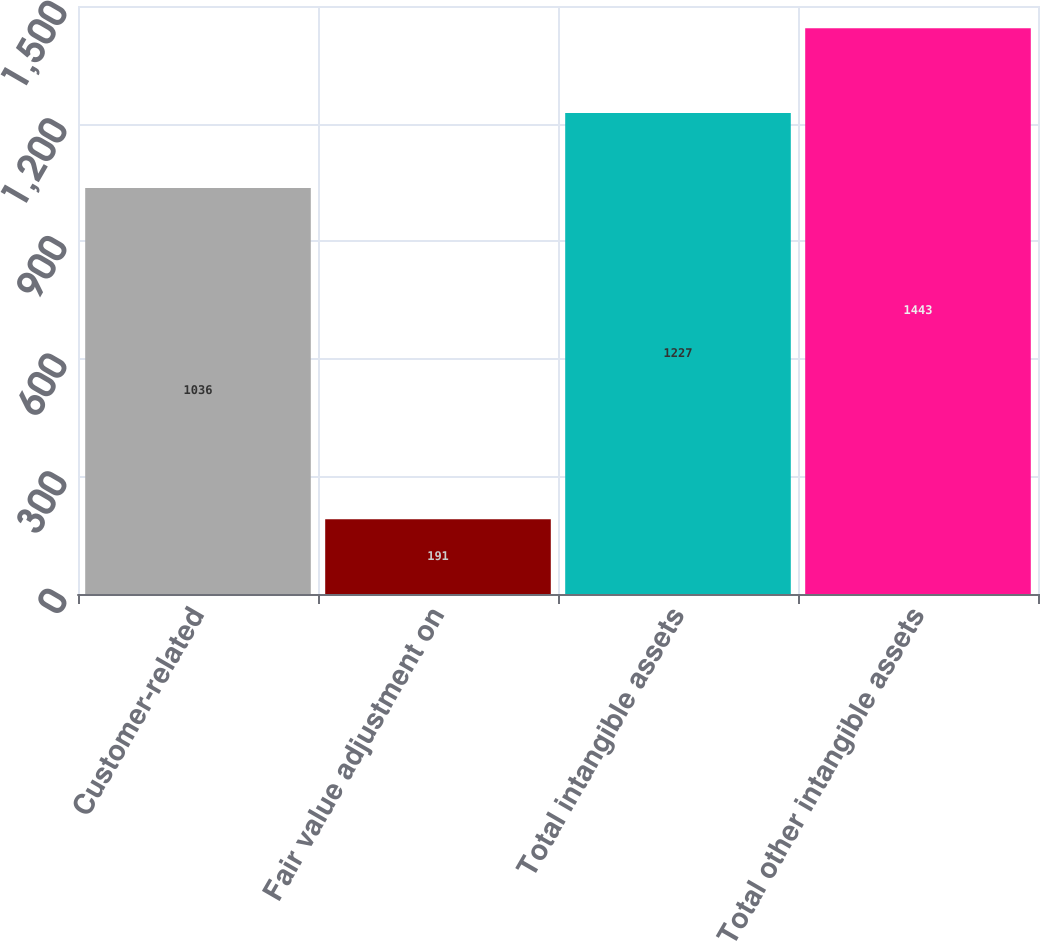Convert chart. <chart><loc_0><loc_0><loc_500><loc_500><bar_chart><fcel>Customer-related<fcel>Fair value adjustment on<fcel>Total intangible assets<fcel>Total other intangible assets<nl><fcel>1036<fcel>191<fcel>1227<fcel>1443<nl></chart> 